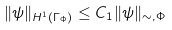<formula> <loc_0><loc_0><loc_500><loc_500>\| \psi \| _ { H ^ { 1 } ( \Gamma _ { \Phi } ) } \leq C _ { 1 } \| \psi \| _ { \sim , \Phi }</formula> 